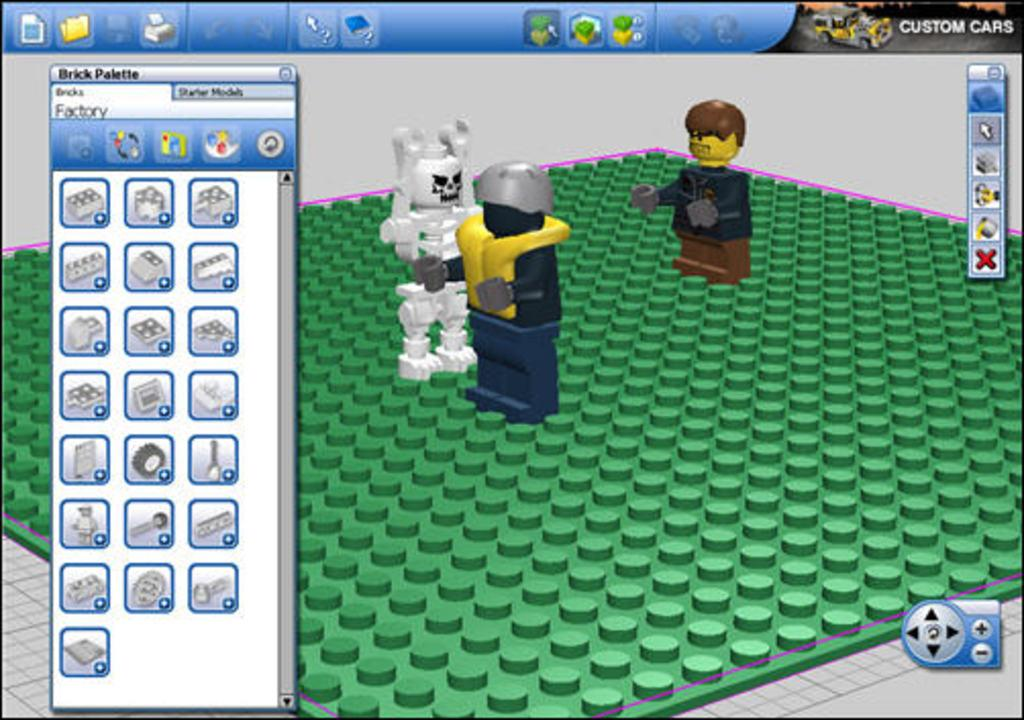<image>
Offer a succinct explanation of the picture presented. a bunch of Lego's with the name brick at the top 